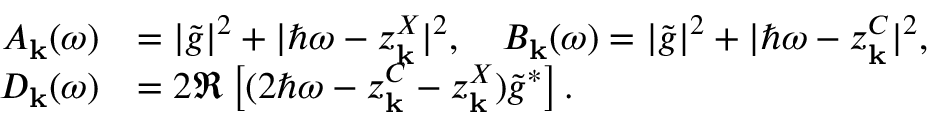<formula> <loc_0><loc_0><loc_500><loc_500>\begin{array} { r l } { A _ { k } ( \omega ) } & { = | \tilde { g } | ^ { 2 } + | \hbar { \omega } - z _ { k } ^ { X } | ^ { 2 } , B _ { k } ( \omega ) = | \tilde { g } | ^ { 2 } + | \hbar { \omega } - z _ { k } ^ { C } | ^ { 2 } , } \\ { D _ { k } ( \omega ) } & { = 2 \Re \left [ ( 2 \hbar { \omega } - z _ { k } ^ { C } - z _ { k } ^ { X } ) \tilde { g } ^ { * } \right ] . } \end{array}</formula> 